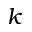Convert formula to latex. <formula><loc_0><loc_0><loc_500><loc_500>k</formula> 